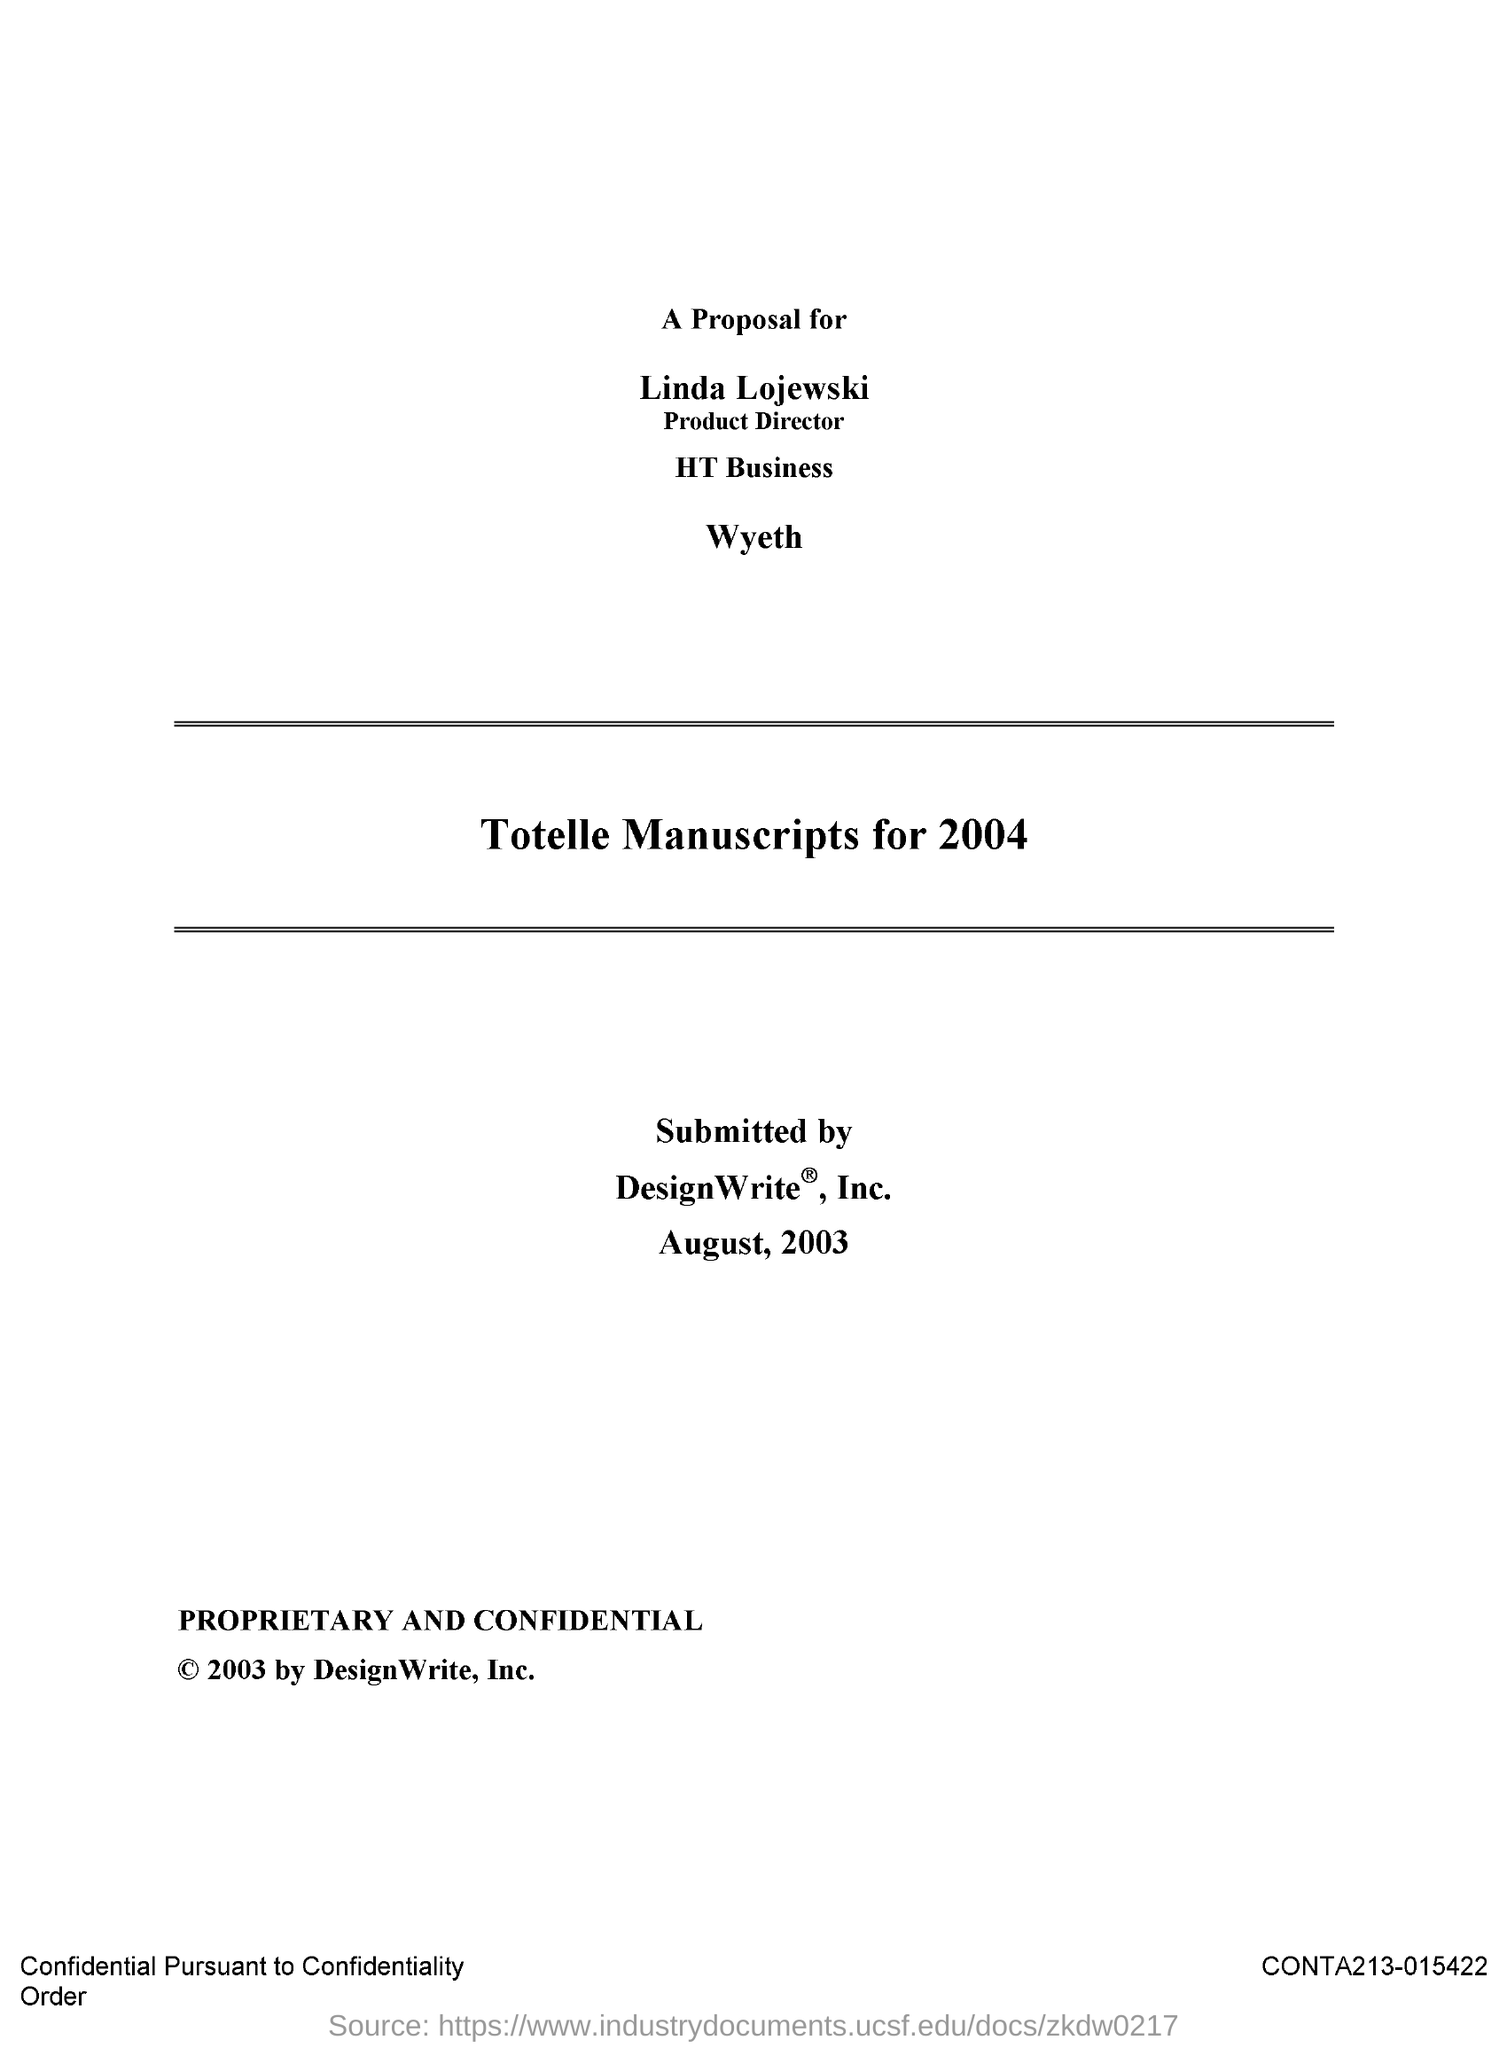Who is the Product Director?
Give a very brief answer. Linda Lojewski. 